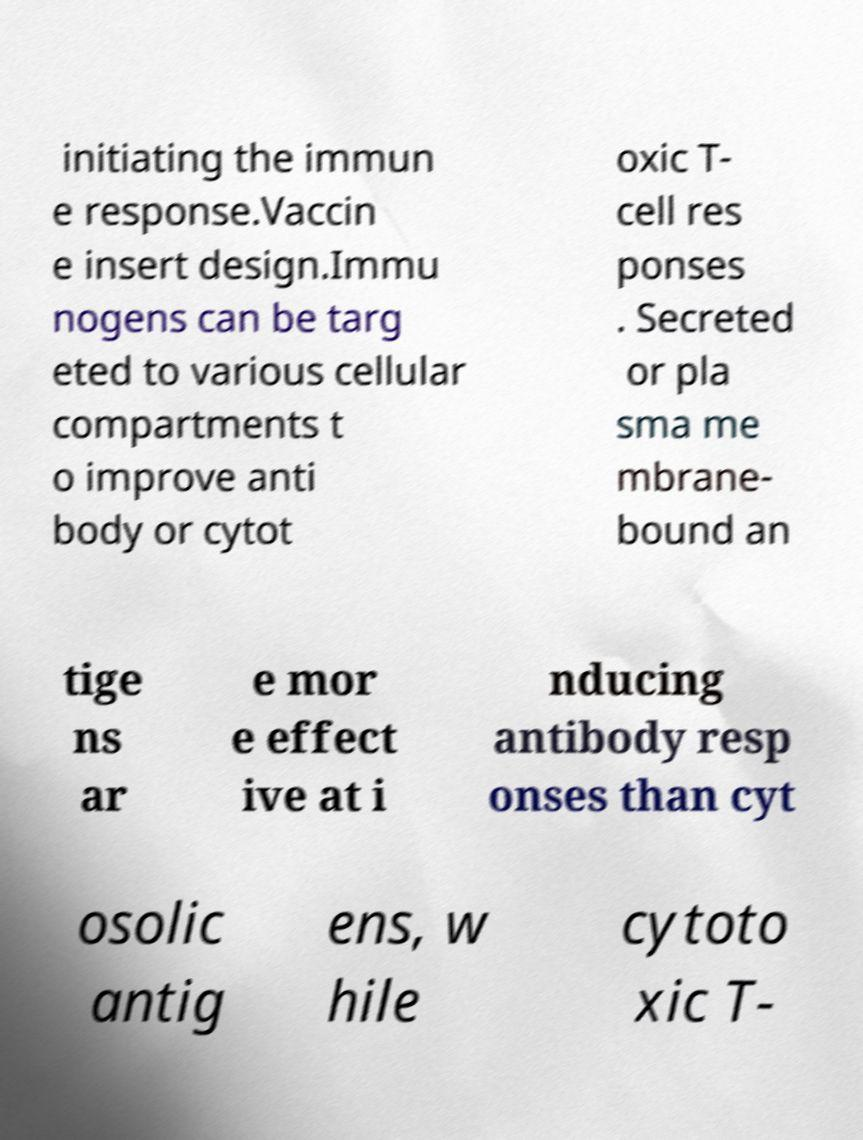What messages or text are displayed in this image? I need them in a readable, typed format. initiating the immun e response.Vaccin e insert design.Immu nogens can be targ eted to various cellular compartments t o improve anti body or cytot oxic T- cell res ponses . Secreted or pla sma me mbrane- bound an tige ns ar e mor e effect ive at i nducing antibody resp onses than cyt osolic antig ens, w hile cytoto xic T- 